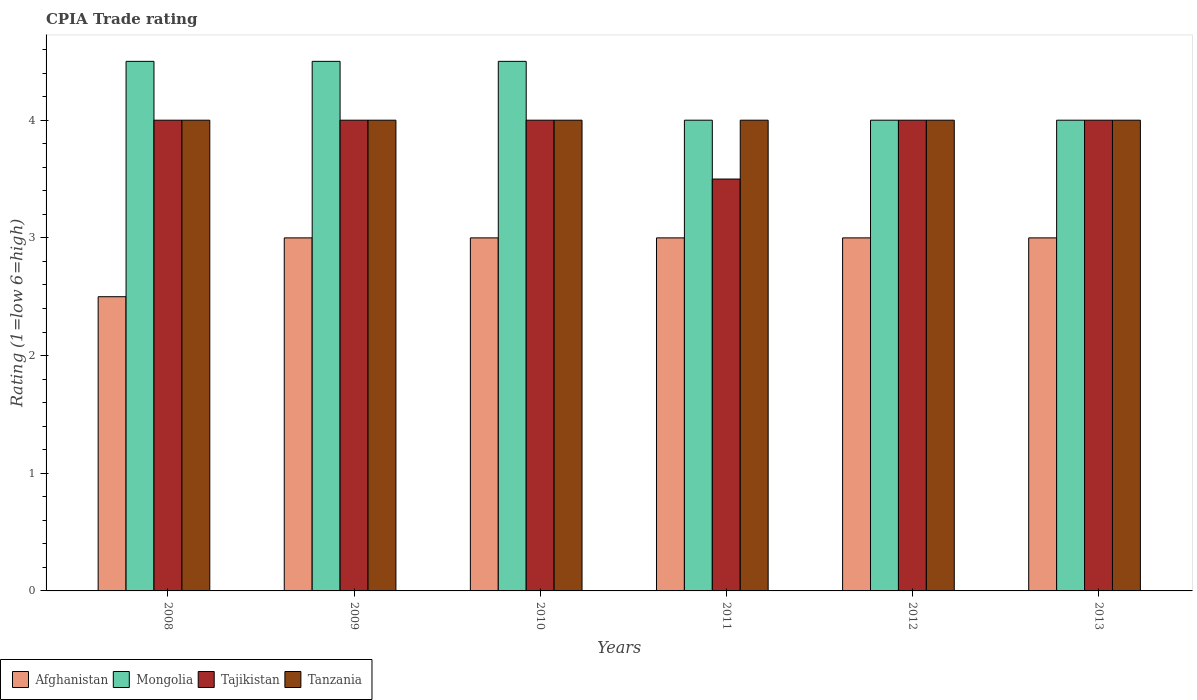How many different coloured bars are there?
Your answer should be compact. 4. How many bars are there on the 2nd tick from the left?
Provide a succinct answer. 4. How many bars are there on the 2nd tick from the right?
Provide a succinct answer. 4. What is the label of the 3rd group of bars from the left?
Your answer should be very brief. 2010. In how many cases, is the number of bars for a given year not equal to the number of legend labels?
Your answer should be compact. 0. What is the CPIA rating in Tanzania in 2009?
Offer a very short reply. 4. Across all years, what is the maximum CPIA rating in Tajikistan?
Offer a terse response. 4. Across all years, what is the minimum CPIA rating in Mongolia?
Provide a succinct answer. 4. In which year was the CPIA rating in Tajikistan maximum?
Provide a succinct answer. 2008. What is the difference between the CPIA rating in Afghanistan in 2010 and that in 2013?
Provide a short and direct response. 0. What is the difference between the CPIA rating in Tanzania in 2010 and the CPIA rating in Tajikistan in 2012?
Provide a short and direct response. 0. What is the average CPIA rating in Tanzania per year?
Provide a succinct answer. 4. What is the ratio of the CPIA rating in Tanzania in 2009 to that in 2011?
Ensure brevity in your answer.  1. Is the difference between the CPIA rating in Tanzania in 2009 and 2013 greater than the difference between the CPIA rating in Tajikistan in 2009 and 2013?
Your response must be concise. No. What is the difference between the highest and the lowest CPIA rating in Tanzania?
Provide a short and direct response. 0. Is it the case that in every year, the sum of the CPIA rating in Mongolia and CPIA rating in Afghanistan is greater than the sum of CPIA rating in Tanzania and CPIA rating in Tajikistan?
Make the answer very short. No. What does the 4th bar from the left in 2011 represents?
Ensure brevity in your answer.  Tanzania. What does the 1st bar from the right in 2009 represents?
Offer a terse response. Tanzania. Is it the case that in every year, the sum of the CPIA rating in Tanzania and CPIA rating in Tajikistan is greater than the CPIA rating in Afghanistan?
Offer a terse response. Yes. Are the values on the major ticks of Y-axis written in scientific E-notation?
Your response must be concise. No. Does the graph contain any zero values?
Provide a short and direct response. No. Does the graph contain grids?
Your response must be concise. No. What is the title of the graph?
Offer a terse response. CPIA Trade rating. Does "Qatar" appear as one of the legend labels in the graph?
Ensure brevity in your answer.  No. What is the Rating (1=low 6=high) in Mongolia in 2008?
Offer a very short reply. 4.5. What is the Rating (1=low 6=high) in Tajikistan in 2008?
Provide a succinct answer. 4. What is the Rating (1=low 6=high) in Tanzania in 2008?
Your answer should be very brief. 4. What is the Rating (1=low 6=high) in Afghanistan in 2009?
Ensure brevity in your answer.  3. What is the Rating (1=low 6=high) in Mongolia in 2009?
Ensure brevity in your answer.  4.5. What is the Rating (1=low 6=high) in Tanzania in 2009?
Your answer should be very brief. 4. What is the Rating (1=low 6=high) of Tanzania in 2010?
Keep it short and to the point. 4. What is the Rating (1=low 6=high) of Afghanistan in 2011?
Keep it short and to the point. 3. What is the Rating (1=low 6=high) in Mongolia in 2011?
Your answer should be very brief. 4. What is the Rating (1=low 6=high) in Afghanistan in 2012?
Provide a succinct answer. 3. What is the Rating (1=low 6=high) of Tajikistan in 2012?
Your response must be concise. 4. What is the Rating (1=low 6=high) of Afghanistan in 2013?
Offer a terse response. 3. What is the Rating (1=low 6=high) of Tajikistan in 2013?
Your answer should be compact. 4. What is the Rating (1=low 6=high) in Tanzania in 2013?
Give a very brief answer. 4. Across all years, what is the maximum Rating (1=low 6=high) of Mongolia?
Provide a short and direct response. 4.5. Across all years, what is the maximum Rating (1=low 6=high) in Tajikistan?
Offer a very short reply. 4. Across all years, what is the minimum Rating (1=low 6=high) of Afghanistan?
Your answer should be very brief. 2.5. Across all years, what is the minimum Rating (1=low 6=high) of Tanzania?
Ensure brevity in your answer.  4. What is the total Rating (1=low 6=high) of Mongolia in the graph?
Your answer should be very brief. 25.5. What is the total Rating (1=low 6=high) of Tajikistan in the graph?
Offer a terse response. 23.5. What is the total Rating (1=low 6=high) of Tanzania in the graph?
Your answer should be very brief. 24. What is the difference between the Rating (1=low 6=high) of Afghanistan in 2008 and that in 2009?
Ensure brevity in your answer.  -0.5. What is the difference between the Rating (1=low 6=high) of Mongolia in 2008 and that in 2011?
Provide a short and direct response. 0.5. What is the difference between the Rating (1=low 6=high) of Tanzania in 2008 and that in 2011?
Make the answer very short. 0. What is the difference between the Rating (1=low 6=high) of Afghanistan in 2008 and that in 2012?
Give a very brief answer. -0.5. What is the difference between the Rating (1=low 6=high) in Tanzania in 2008 and that in 2012?
Ensure brevity in your answer.  0. What is the difference between the Rating (1=low 6=high) in Tajikistan in 2008 and that in 2013?
Your answer should be compact. 0. What is the difference between the Rating (1=low 6=high) of Afghanistan in 2009 and that in 2010?
Provide a succinct answer. 0. What is the difference between the Rating (1=low 6=high) of Mongolia in 2009 and that in 2010?
Provide a succinct answer. 0. What is the difference between the Rating (1=low 6=high) in Tajikistan in 2009 and that in 2010?
Offer a very short reply. 0. What is the difference between the Rating (1=low 6=high) in Tanzania in 2009 and that in 2010?
Offer a very short reply. 0. What is the difference between the Rating (1=low 6=high) in Mongolia in 2009 and that in 2011?
Keep it short and to the point. 0.5. What is the difference between the Rating (1=low 6=high) in Tajikistan in 2009 and that in 2011?
Your response must be concise. 0.5. What is the difference between the Rating (1=low 6=high) in Mongolia in 2009 and that in 2012?
Offer a terse response. 0.5. What is the difference between the Rating (1=low 6=high) in Tajikistan in 2009 and that in 2012?
Make the answer very short. 0. What is the difference between the Rating (1=low 6=high) of Tanzania in 2009 and that in 2013?
Offer a terse response. 0. What is the difference between the Rating (1=low 6=high) of Afghanistan in 2010 and that in 2011?
Offer a very short reply. 0. What is the difference between the Rating (1=low 6=high) of Tajikistan in 2010 and that in 2011?
Offer a very short reply. 0.5. What is the difference between the Rating (1=low 6=high) of Mongolia in 2010 and that in 2012?
Provide a succinct answer. 0.5. What is the difference between the Rating (1=low 6=high) in Tajikistan in 2010 and that in 2012?
Your answer should be very brief. 0. What is the difference between the Rating (1=low 6=high) in Tanzania in 2010 and that in 2012?
Give a very brief answer. 0. What is the difference between the Rating (1=low 6=high) of Mongolia in 2010 and that in 2013?
Your response must be concise. 0.5. What is the difference between the Rating (1=low 6=high) of Tajikistan in 2010 and that in 2013?
Offer a very short reply. 0. What is the difference between the Rating (1=low 6=high) of Tanzania in 2010 and that in 2013?
Ensure brevity in your answer.  0. What is the difference between the Rating (1=low 6=high) of Afghanistan in 2011 and that in 2012?
Offer a very short reply. 0. What is the difference between the Rating (1=low 6=high) of Mongolia in 2011 and that in 2013?
Make the answer very short. 0. What is the difference between the Rating (1=low 6=high) of Tajikistan in 2011 and that in 2013?
Provide a short and direct response. -0.5. What is the difference between the Rating (1=low 6=high) of Tanzania in 2011 and that in 2013?
Your response must be concise. 0. What is the difference between the Rating (1=low 6=high) in Afghanistan in 2012 and that in 2013?
Your answer should be compact. 0. What is the difference between the Rating (1=low 6=high) of Mongolia in 2012 and that in 2013?
Give a very brief answer. 0. What is the difference between the Rating (1=low 6=high) in Tanzania in 2012 and that in 2013?
Provide a succinct answer. 0. What is the difference between the Rating (1=low 6=high) of Afghanistan in 2008 and the Rating (1=low 6=high) of Tajikistan in 2009?
Offer a terse response. -1.5. What is the difference between the Rating (1=low 6=high) in Afghanistan in 2008 and the Rating (1=low 6=high) in Tanzania in 2009?
Ensure brevity in your answer.  -1.5. What is the difference between the Rating (1=low 6=high) of Mongolia in 2008 and the Rating (1=low 6=high) of Tajikistan in 2009?
Ensure brevity in your answer.  0.5. What is the difference between the Rating (1=low 6=high) in Mongolia in 2008 and the Rating (1=low 6=high) in Tanzania in 2009?
Ensure brevity in your answer.  0.5. What is the difference between the Rating (1=low 6=high) of Afghanistan in 2008 and the Rating (1=low 6=high) of Mongolia in 2010?
Offer a terse response. -2. What is the difference between the Rating (1=low 6=high) of Afghanistan in 2008 and the Rating (1=low 6=high) of Tajikistan in 2010?
Ensure brevity in your answer.  -1.5. What is the difference between the Rating (1=low 6=high) of Mongolia in 2008 and the Rating (1=low 6=high) of Tajikistan in 2010?
Your answer should be very brief. 0.5. What is the difference between the Rating (1=low 6=high) in Mongolia in 2008 and the Rating (1=low 6=high) in Tanzania in 2010?
Give a very brief answer. 0.5. What is the difference between the Rating (1=low 6=high) in Afghanistan in 2008 and the Rating (1=low 6=high) in Mongolia in 2011?
Offer a terse response. -1.5. What is the difference between the Rating (1=low 6=high) of Afghanistan in 2008 and the Rating (1=low 6=high) of Tanzania in 2011?
Offer a terse response. -1.5. What is the difference between the Rating (1=low 6=high) in Tajikistan in 2008 and the Rating (1=low 6=high) in Tanzania in 2011?
Provide a succinct answer. 0. What is the difference between the Rating (1=low 6=high) of Afghanistan in 2008 and the Rating (1=low 6=high) of Mongolia in 2012?
Offer a very short reply. -1.5. What is the difference between the Rating (1=low 6=high) of Afghanistan in 2008 and the Rating (1=low 6=high) of Tajikistan in 2012?
Your answer should be compact. -1.5. What is the difference between the Rating (1=low 6=high) of Tajikistan in 2008 and the Rating (1=low 6=high) of Tanzania in 2012?
Keep it short and to the point. 0. What is the difference between the Rating (1=low 6=high) of Afghanistan in 2008 and the Rating (1=low 6=high) of Tajikistan in 2013?
Make the answer very short. -1.5. What is the difference between the Rating (1=low 6=high) of Afghanistan in 2008 and the Rating (1=low 6=high) of Tanzania in 2013?
Provide a short and direct response. -1.5. What is the difference between the Rating (1=low 6=high) in Mongolia in 2008 and the Rating (1=low 6=high) in Tajikistan in 2013?
Provide a short and direct response. 0.5. What is the difference between the Rating (1=low 6=high) of Tajikistan in 2008 and the Rating (1=low 6=high) of Tanzania in 2013?
Offer a terse response. 0. What is the difference between the Rating (1=low 6=high) in Afghanistan in 2009 and the Rating (1=low 6=high) in Tanzania in 2010?
Your answer should be compact. -1. What is the difference between the Rating (1=low 6=high) in Mongolia in 2009 and the Rating (1=low 6=high) in Tajikistan in 2010?
Offer a terse response. 0.5. What is the difference between the Rating (1=low 6=high) of Mongolia in 2009 and the Rating (1=low 6=high) of Tanzania in 2010?
Keep it short and to the point. 0.5. What is the difference between the Rating (1=low 6=high) of Afghanistan in 2009 and the Rating (1=low 6=high) of Mongolia in 2011?
Offer a terse response. -1. What is the difference between the Rating (1=low 6=high) of Afghanistan in 2009 and the Rating (1=low 6=high) of Tajikistan in 2011?
Your answer should be very brief. -0.5. What is the difference between the Rating (1=low 6=high) of Mongolia in 2009 and the Rating (1=low 6=high) of Tajikistan in 2011?
Offer a terse response. 1. What is the difference between the Rating (1=low 6=high) of Afghanistan in 2009 and the Rating (1=low 6=high) of Mongolia in 2012?
Keep it short and to the point. -1. What is the difference between the Rating (1=low 6=high) in Afghanistan in 2009 and the Rating (1=low 6=high) in Tajikistan in 2012?
Your response must be concise. -1. What is the difference between the Rating (1=low 6=high) of Mongolia in 2009 and the Rating (1=low 6=high) of Tanzania in 2012?
Your answer should be compact. 0.5. What is the difference between the Rating (1=low 6=high) of Tajikistan in 2009 and the Rating (1=low 6=high) of Tanzania in 2012?
Your answer should be compact. 0. What is the difference between the Rating (1=low 6=high) in Afghanistan in 2009 and the Rating (1=low 6=high) in Mongolia in 2013?
Ensure brevity in your answer.  -1. What is the difference between the Rating (1=low 6=high) in Afghanistan in 2009 and the Rating (1=low 6=high) in Tanzania in 2013?
Offer a very short reply. -1. What is the difference between the Rating (1=low 6=high) in Mongolia in 2009 and the Rating (1=low 6=high) in Tanzania in 2013?
Ensure brevity in your answer.  0.5. What is the difference between the Rating (1=low 6=high) of Afghanistan in 2010 and the Rating (1=low 6=high) of Mongolia in 2011?
Make the answer very short. -1. What is the difference between the Rating (1=low 6=high) of Afghanistan in 2010 and the Rating (1=low 6=high) of Tanzania in 2011?
Ensure brevity in your answer.  -1. What is the difference between the Rating (1=low 6=high) in Afghanistan in 2010 and the Rating (1=low 6=high) in Mongolia in 2012?
Ensure brevity in your answer.  -1. What is the difference between the Rating (1=low 6=high) of Afghanistan in 2010 and the Rating (1=low 6=high) of Tanzania in 2012?
Offer a terse response. -1. What is the difference between the Rating (1=low 6=high) of Mongolia in 2010 and the Rating (1=low 6=high) of Tanzania in 2012?
Offer a very short reply. 0.5. What is the difference between the Rating (1=low 6=high) of Afghanistan in 2010 and the Rating (1=low 6=high) of Mongolia in 2013?
Your response must be concise. -1. What is the difference between the Rating (1=low 6=high) in Afghanistan in 2010 and the Rating (1=low 6=high) in Tajikistan in 2013?
Provide a short and direct response. -1. What is the difference between the Rating (1=low 6=high) of Afghanistan in 2010 and the Rating (1=low 6=high) of Tanzania in 2013?
Your response must be concise. -1. What is the difference between the Rating (1=low 6=high) of Mongolia in 2010 and the Rating (1=low 6=high) of Tanzania in 2013?
Provide a short and direct response. 0.5. What is the difference between the Rating (1=low 6=high) of Tajikistan in 2010 and the Rating (1=low 6=high) of Tanzania in 2013?
Offer a terse response. 0. What is the difference between the Rating (1=low 6=high) in Afghanistan in 2011 and the Rating (1=low 6=high) in Tanzania in 2012?
Provide a succinct answer. -1. What is the difference between the Rating (1=low 6=high) in Afghanistan in 2011 and the Rating (1=low 6=high) in Tajikistan in 2013?
Ensure brevity in your answer.  -1. What is the difference between the Rating (1=low 6=high) of Afghanistan in 2012 and the Rating (1=low 6=high) of Tajikistan in 2013?
Ensure brevity in your answer.  -1. What is the difference between the Rating (1=low 6=high) of Afghanistan in 2012 and the Rating (1=low 6=high) of Tanzania in 2013?
Keep it short and to the point. -1. What is the difference between the Rating (1=low 6=high) in Mongolia in 2012 and the Rating (1=low 6=high) in Tanzania in 2013?
Keep it short and to the point. 0. What is the average Rating (1=low 6=high) of Afghanistan per year?
Make the answer very short. 2.92. What is the average Rating (1=low 6=high) of Mongolia per year?
Provide a short and direct response. 4.25. What is the average Rating (1=low 6=high) of Tajikistan per year?
Your answer should be very brief. 3.92. What is the average Rating (1=low 6=high) of Tanzania per year?
Give a very brief answer. 4. In the year 2008, what is the difference between the Rating (1=low 6=high) in Afghanistan and Rating (1=low 6=high) in Tajikistan?
Give a very brief answer. -1.5. In the year 2008, what is the difference between the Rating (1=low 6=high) in Afghanistan and Rating (1=low 6=high) in Tanzania?
Offer a terse response. -1.5. In the year 2008, what is the difference between the Rating (1=low 6=high) of Mongolia and Rating (1=low 6=high) of Tanzania?
Offer a terse response. 0.5. In the year 2009, what is the difference between the Rating (1=low 6=high) in Afghanistan and Rating (1=low 6=high) in Tajikistan?
Your answer should be very brief. -1. In the year 2009, what is the difference between the Rating (1=low 6=high) in Afghanistan and Rating (1=low 6=high) in Tanzania?
Your answer should be very brief. -1. In the year 2009, what is the difference between the Rating (1=low 6=high) of Mongolia and Rating (1=low 6=high) of Tanzania?
Offer a terse response. 0.5. In the year 2009, what is the difference between the Rating (1=low 6=high) of Tajikistan and Rating (1=low 6=high) of Tanzania?
Make the answer very short. 0. In the year 2010, what is the difference between the Rating (1=low 6=high) in Afghanistan and Rating (1=low 6=high) in Mongolia?
Your answer should be compact. -1.5. In the year 2010, what is the difference between the Rating (1=low 6=high) in Afghanistan and Rating (1=low 6=high) in Tanzania?
Make the answer very short. -1. In the year 2011, what is the difference between the Rating (1=low 6=high) in Afghanistan and Rating (1=low 6=high) in Tanzania?
Provide a short and direct response. -1. In the year 2011, what is the difference between the Rating (1=low 6=high) in Mongolia and Rating (1=low 6=high) in Tajikistan?
Your answer should be compact. 0.5. In the year 2011, what is the difference between the Rating (1=low 6=high) in Mongolia and Rating (1=low 6=high) in Tanzania?
Offer a terse response. 0. In the year 2011, what is the difference between the Rating (1=low 6=high) of Tajikistan and Rating (1=low 6=high) of Tanzania?
Your answer should be compact. -0.5. In the year 2012, what is the difference between the Rating (1=low 6=high) of Afghanistan and Rating (1=low 6=high) of Mongolia?
Make the answer very short. -1. In the year 2012, what is the difference between the Rating (1=low 6=high) in Mongolia and Rating (1=low 6=high) in Tajikistan?
Your answer should be compact. 0. In the year 2013, what is the difference between the Rating (1=low 6=high) of Afghanistan and Rating (1=low 6=high) of Mongolia?
Your answer should be compact. -1. In the year 2013, what is the difference between the Rating (1=low 6=high) of Afghanistan and Rating (1=low 6=high) of Tajikistan?
Ensure brevity in your answer.  -1. In the year 2013, what is the difference between the Rating (1=low 6=high) of Mongolia and Rating (1=low 6=high) of Tajikistan?
Provide a short and direct response. 0. In the year 2013, what is the difference between the Rating (1=low 6=high) of Mongolia and Rating (1=low 6=high) of Tanzania?
Keep it short and to the point. 0. What is the ratio of the Rating (1=low 6=high) in Afghanistan in 2008 to that in 2009?
Your answer should be very brief. 0.83. What is the ratio of the Rating (1=low 6=high) of Tajikistan in 2008 to that in 2009?
Your answer should be compact. 1. What is the ratio of the Rating (1=low 6=high) of Tajikistan in 2008 to that in 2011?
Keep it short and to the point. 1.14. What is the ratio of the Rating (1=low 6=high) in Mongolia in 2008 to that in 2012?
Your response must be concise. 1.12. What is the ratio of the Rating (1=low 6=high) in Tajikistan in 2008 to that in 2012?
Your answer should be very brief. 1. What is the ratio of the Rating (1=low 6=high) of Afghanistan in 2008 to that in 2013?
Your answer should be compact. 0.83. What is the ratio of the Rating (1=low 6=high) of Tanzania in 2008 to that in 2013?
Keep it short and to the point. 1. What is the ratio of the Rating (1=low 6=high) of Afghanistan in 2009 to that in 2010?
Give a very brief answer. 1. What is the ratio of the Rating (1=low 6=high) in Tanzania in 2009 to that in 2010?
Provide a succinct answer. 1. What is the ratio of the Rating (1=low 6=high) in Afghanistan in 2009 to that in 2011?
Provide a succinct answer. 1. What is the ratio of the Rating (1=low 6=high) in Tanzania in 2009 to that in 2011?
Your answer should be very brief. 1. What is the ratio of the Rating (1=low 6=high) of Mongolia in 2009 to that in 2012?
Give a very brief answer. 1.12. What is the ratio of the Rating (1=low 6=high) of Tanzania in 2009 to that in 2012?
Provide a short and direct response. 1. What is the ratio of the Rating (1=low 6=high) of Tajikistan in 2009 to that in 2013?
Make the answer very short. 1. What is the ratio of the Rating (1=low 6=high) in Tanzania in 2009 to that in 2013?
Offer a very short reply. 1. What is the ratio of the Rating (1=low 6=high) in Afghanistan in 2010 to that in 2011?
Provide a short and direct response. 1. What is the ratio of the Rating (1=low 6=high) in Mongolia in 2010 to that in 2012?
Your answer should be very brief. 1.12. What is the ratio of the Rating (1=low 6=high) in Tajikistan in 2010 to that in 2012?
Provide a succinct answer. 1. What is the ratio of the Rating (1=low 6=high) in Tanzania in 2010 to that in 2012?
Your answer should be compact. 1. What is the ratio of the Rating (1=low 6=high) of Afghanistan in 2010 to that in 2013?
Give a very brief answer. 1. What is the ratio of the Rating (1=low 6=high) in Afghanistan in 2011 to that in 2012?
Provide a short and direct response. 1. What is the ratio of the Rating (1=low 6=high) of Mongolia in 2011 to that in 2012?
Make the answer very short. 1. What is the ratio of the Rating (1=low 6=high) of Tajikistan in 2011 to that in 2012?
Ensure brevity in your answer.  0.88. What is the ratio of the Rating (1=low 6=high) of Mongolia in 2012 to that in 2013?
Provide a short and direct response. 1. What is the ratio of the Rating (1=low 6=high) in Tanzania in 2012 to that in 2013?
Give a very brief answer. 1. What is the difference between the highest and the lowest Rating (1=low 6=high) in Afghanistan?
Offer a very short reply. 0.5. What is the difference between the highest and the lowest Rating (1=low 6=high) in Mongolia?
Make the answer very short. 0.5. What is the difference between the highest and the lowest Rating (1=low 6=high) in Tajikistan?
Your response must be concise. 0.5. 